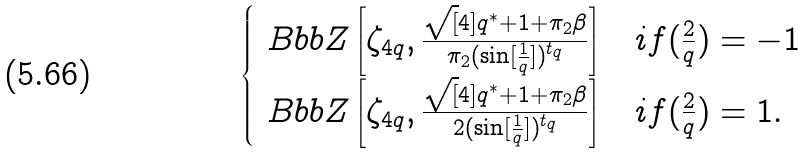<formula> <loc_0><loc_0><loc_500><loc_500>\begin{cases} \ B b b Z \left [ \zeta _ { 4 q } , \frac { \sqrt { [ } 4 ] { q ^ { * } } + 1 + \pi _ { 2 } \beta } { \pi _ { 2 } ( \sin [ \frac { 1 } { q } ] ) ^ { t _ { q } } } \right ] & i f ( \frac { 2 } { q } ) = - 1 \\ \ B b b Z \left [ \zeta _ { 4 q } , \frac { \sqrt { [ } 4 ] { q ^ { * } } + 1 + \pi _ { 2 } \beta } { 2 ( \sin [ \frac { 1 } { q } ] ) ^ { t _ { q } } } \right ] & i f ( \frac { 2 } { q } ) = 1 . \end{cases}</formula> 